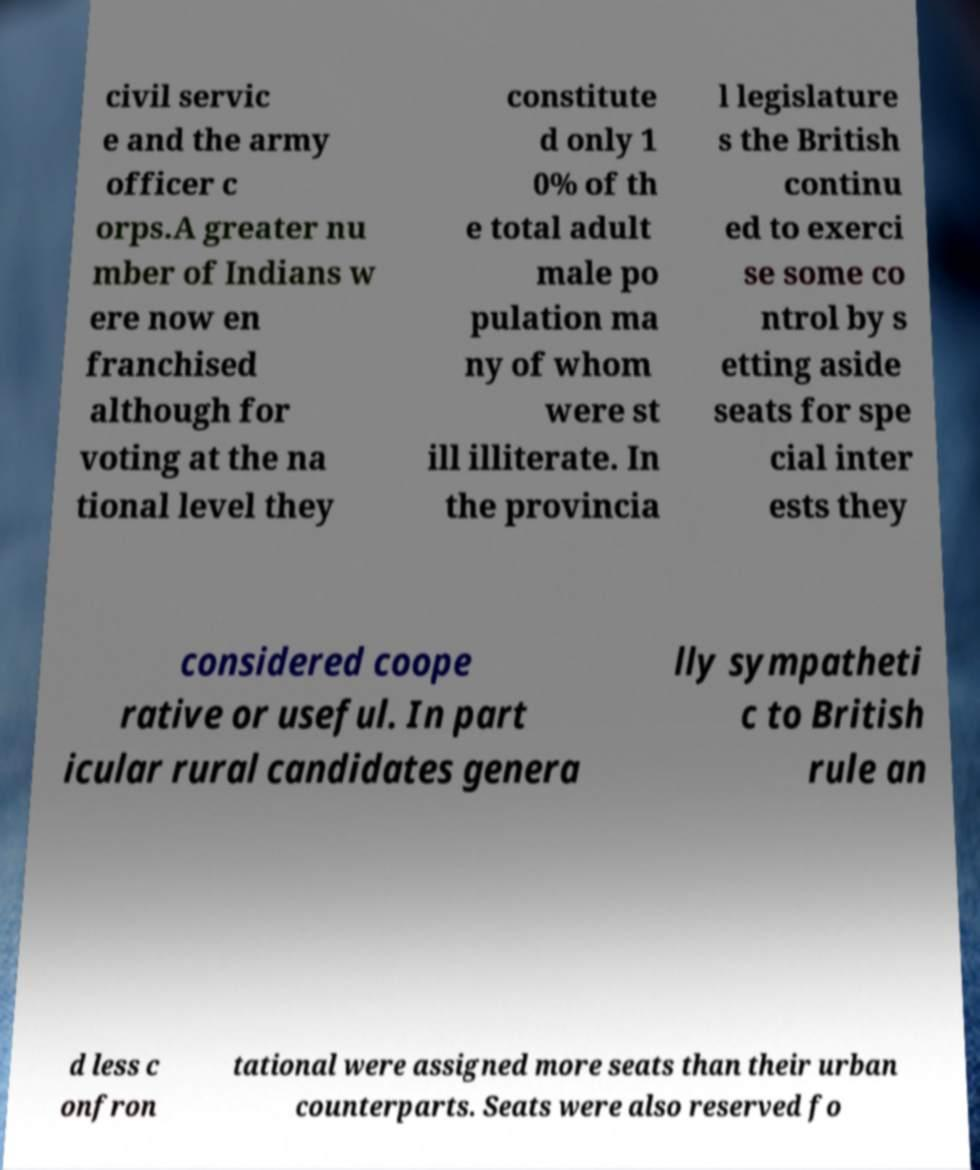What messages or text are displayed in this image? I need them in a readable, typed format. civil servic e and the army officer c orps.A greater nu mber of Indians w ere now en franchised although for voting at the na tional level they constitute d only 1 0% of th e total adult male po pulation ma ny of whom were st ill illiterate. In the provincia l legislature s the British continu ed to exerci se some co ntrol by s etting aside seats for spe cial inter ests they considered coope rative or useful. In part icular rural candidates genera lly sympatheti c to British rule an d less c onfron tational were assigned more seats than their urban counterparts. Seats were also reserved fo 